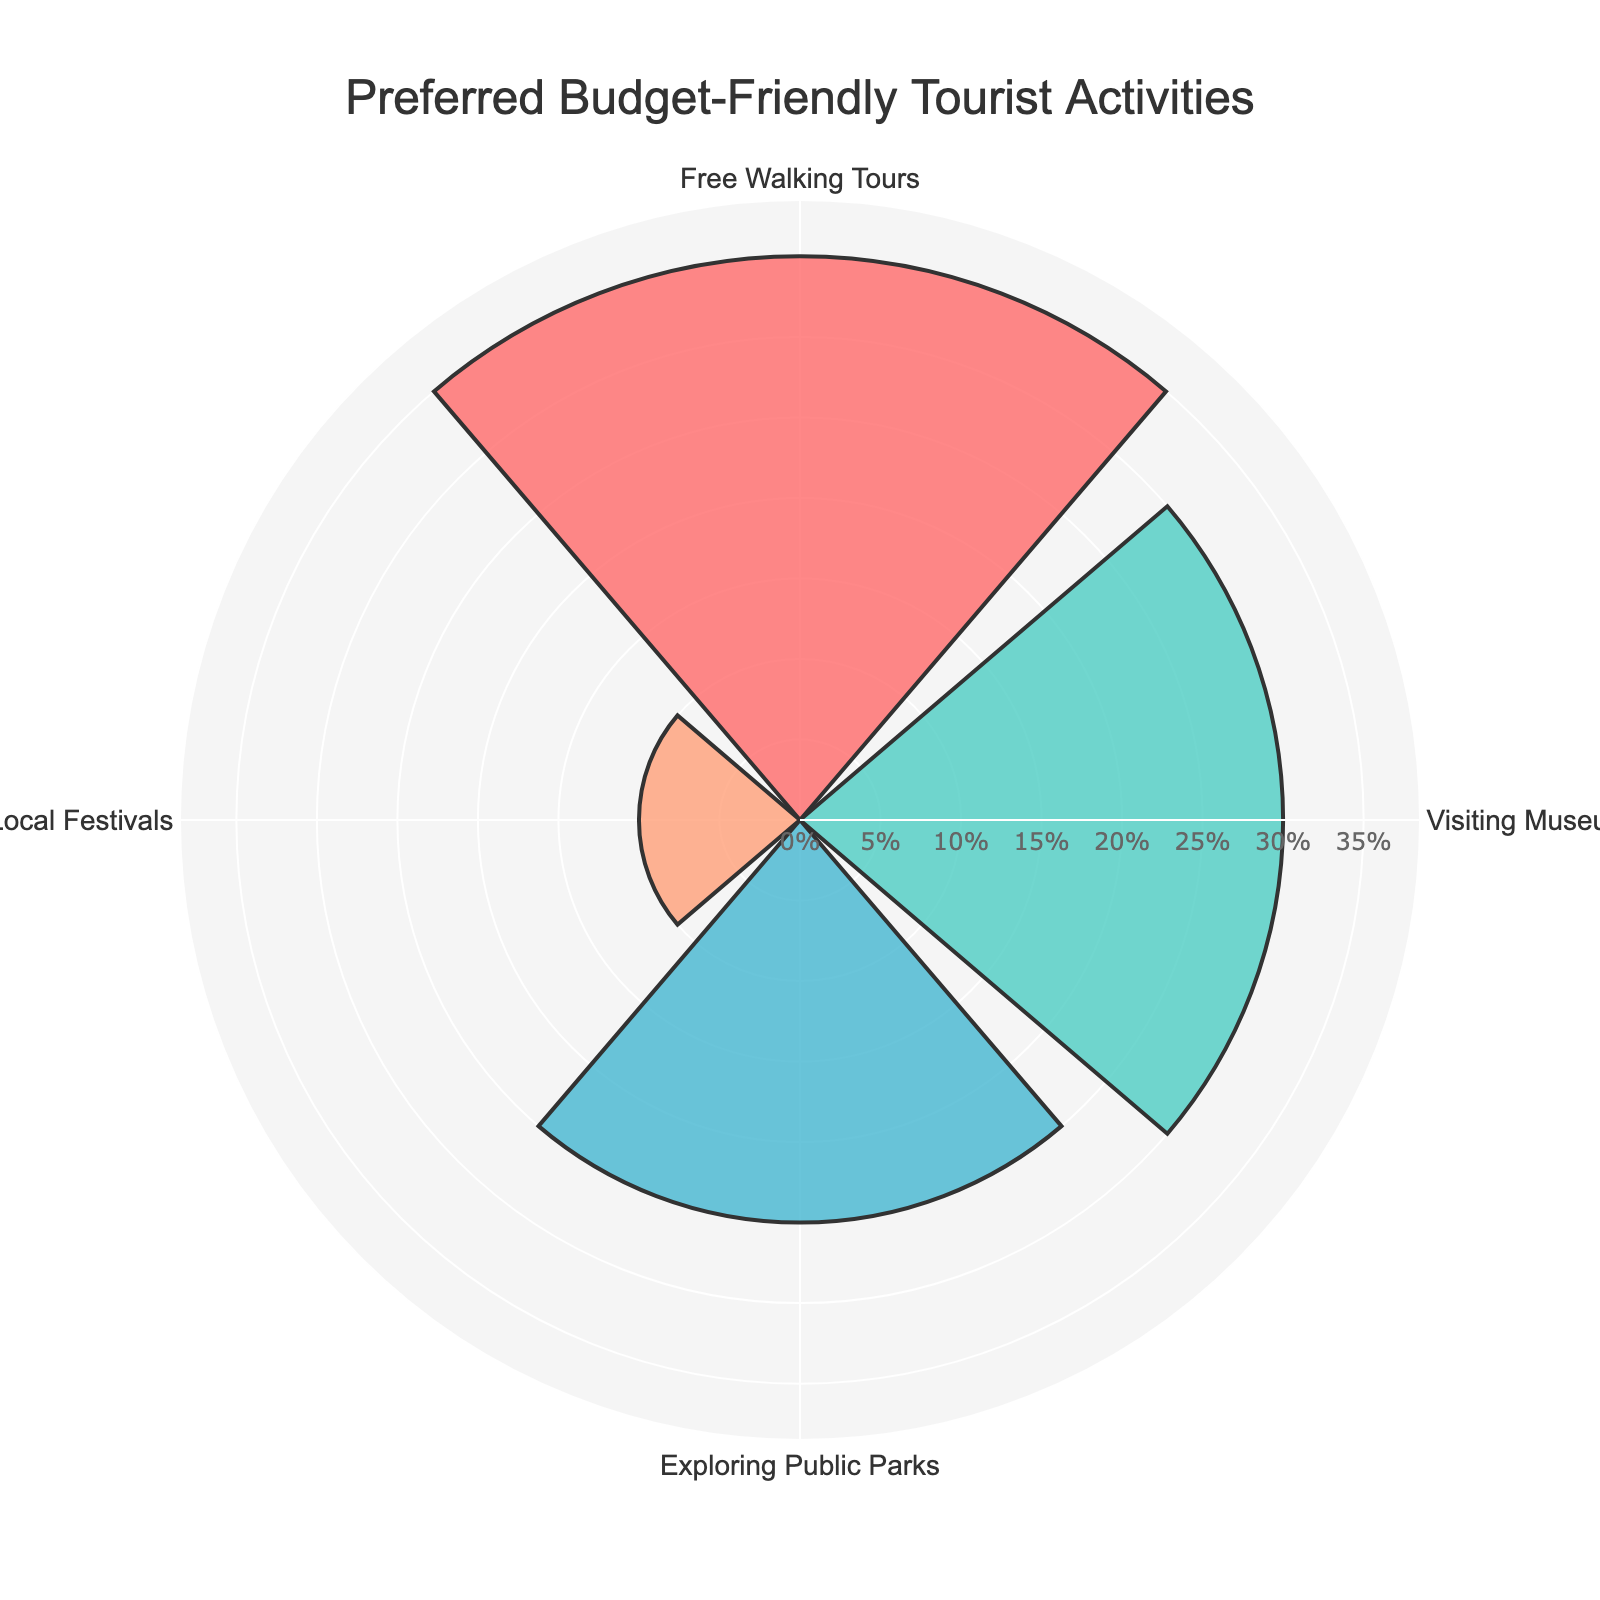What's the title of the figure? The title of the figure is usually placed at the top of the figure, centered and bolded, making it easy to identify.
Answer: Preferred Budget-Friendly Tourist Activities Which activity is preferred by the highest percentage of tourists? Look for the segment with the largest radial distance on the rose chart.
Answer: Free Walking Tours What's the combined percentage of tourists who prefer Visiting Museums with Free Entry and Exploring Public Parks? Add the percentages of both categories: Visiting Museums with Free Entry (30%) and Exploring Public Parks (25%).
Answer: 55% How much less popular is Attending Local Festivals compared to Free Walking Tours? Subtract the percentage of Attending Local Festivals (10%) from the percentage of Free Walking Tours (35%).
Answer: 25% Which activities have a preference percentage greater than 25%? Identify activities with percentages higher than 25% by examining the radial distances.
Answer: Free Walking Tours and Visiting Museums with Free Entry How many categories are there in the figure? Count the number of unique segments or labels in the rose chart.
Answer: 4 Which activity has the lowest preference percentage and what is it? Identify the segment with the smallest radial distance.
Answer: Attending Local Festivals, 10% Are there any activities with equal preference percentages? Check if any segments have the same length on the rose chart.
Answer: No What's the difference in preference percentage between Visiting Museums with Free Entry and Exploring Public Parks? Subtract the percentage of Exploring Public Parks (25%) from the percentage of Visiting Museums with Free Entry (30%).
Answer: 5% Is Visiting Museums with Free Entry more popular than Exploring Public Parks? Compare the percentages of the two activities: 30% vs. 25%.
Answer: Yes 